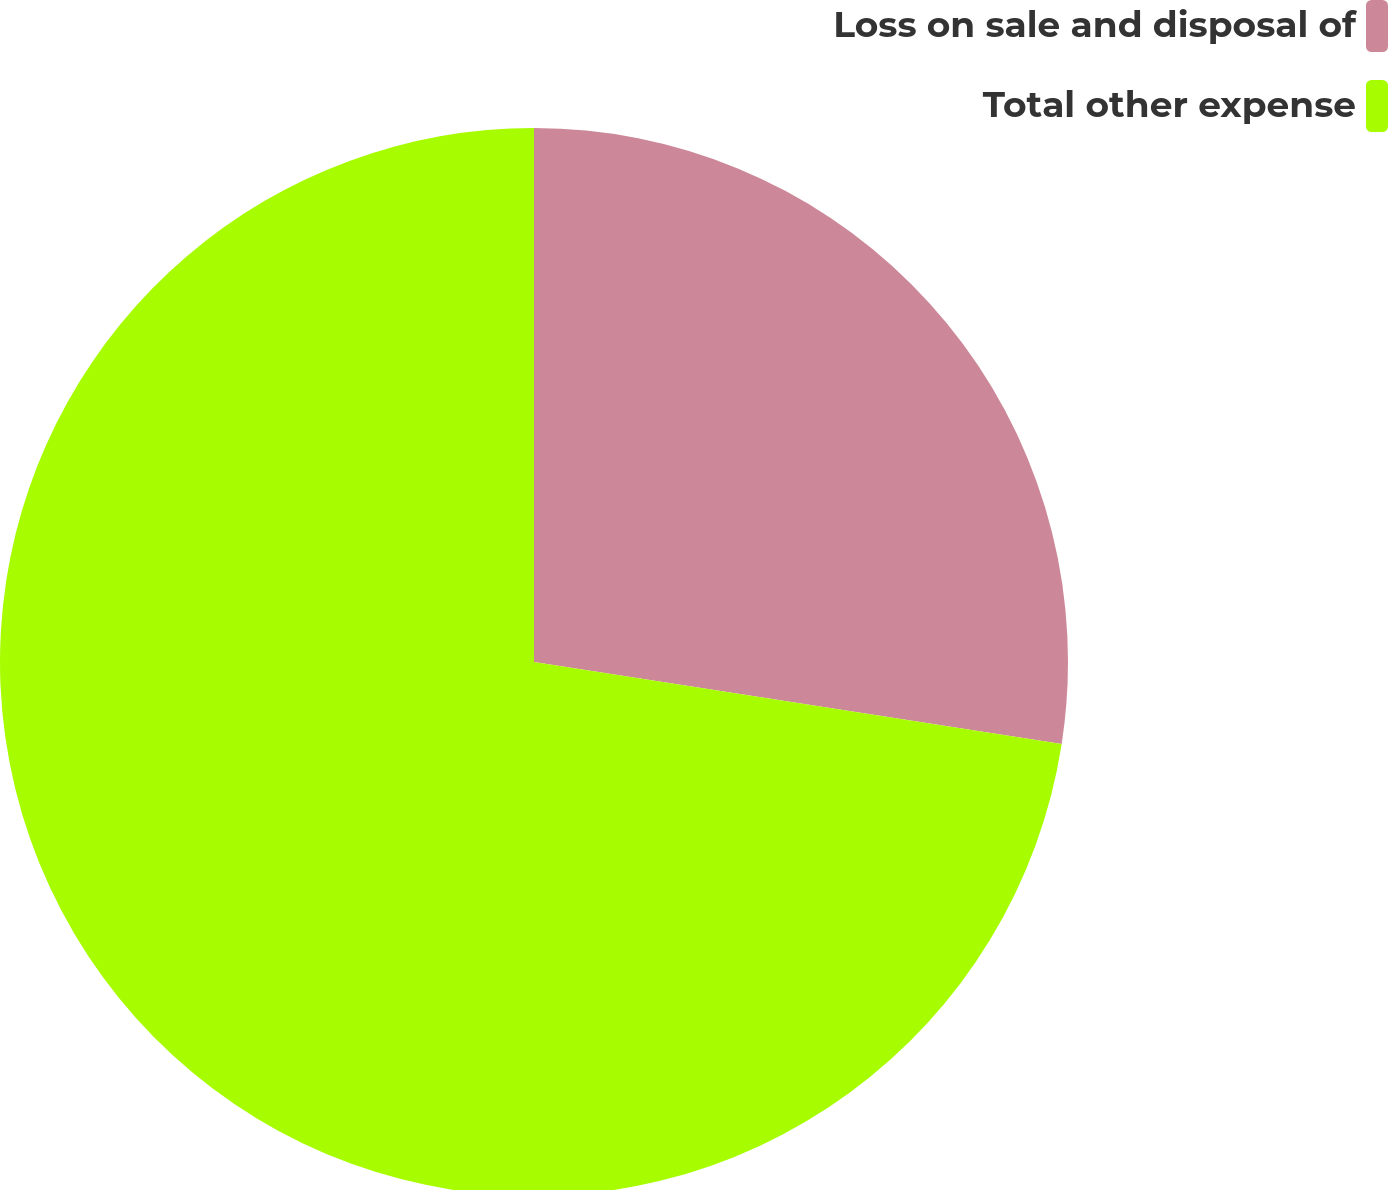Convert chart. <chart><loc_0><loc_0><loc_500><loc_500><pie_chart><fcel>Loss on sale and disposal of<fcel>Total other expense<nl><fcel>27.45%<fcel>72.55%<nl></chart> 